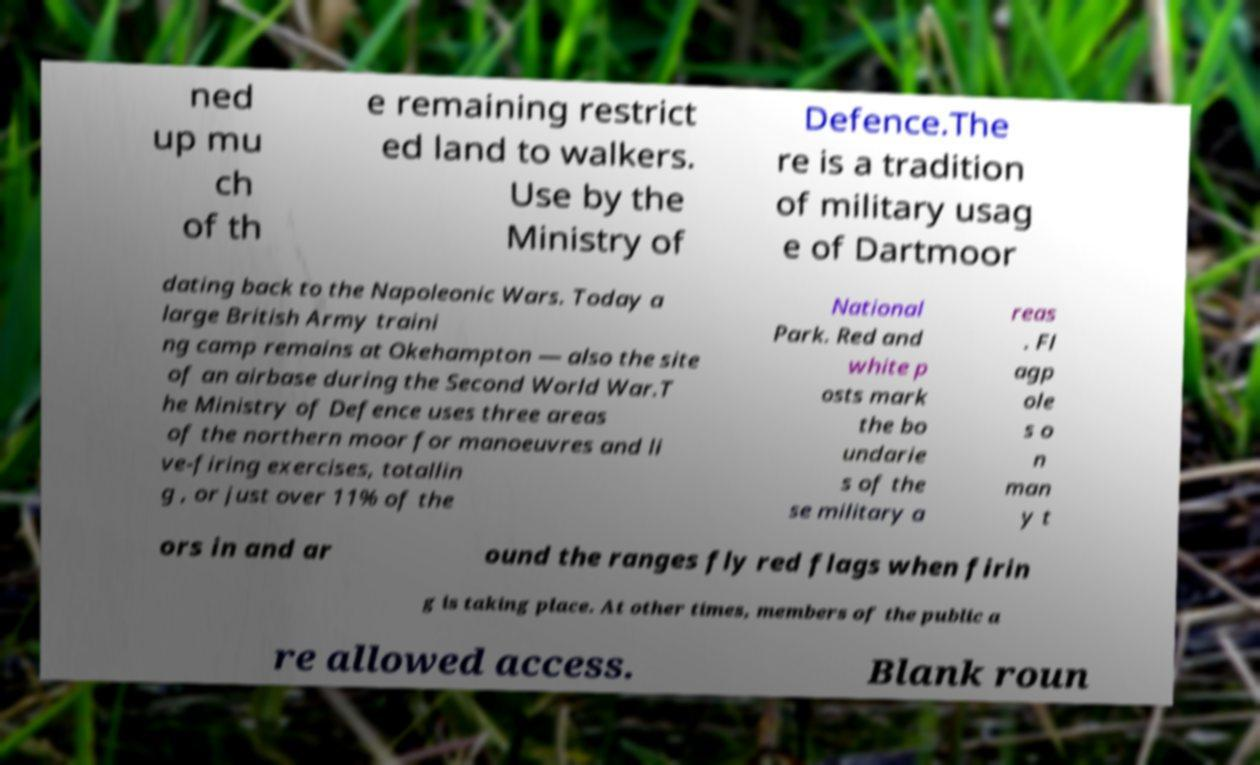Please read and relay the text visible in this image. What does it say? ned up mu ch of th e remaining restrict ed land to walkers. Use by the Ministry of Defence.The re is a tradition of military usag e of Dartmoor dating back to the Napoleonic Wars. Today a large British Army traini ng camp remains at Okehampton — also the site of an airbase during the Second World War.T he Ministry of Defence uses three areas of the northern moor for manoeuvres and li ve-firing exercises, totallin g , or just over 11% of the National Park. Red and white p osts mark the bo undarie s of the se military a reas . Fl agp ole s o n man y t ors in and ar ound the ranges fly red flags when firin g is taking place. At other times, members of the public a re allowed access. Blank roun 